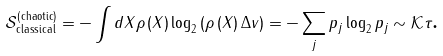<formula> <loc_0><loc_0><loc_500><loc_500>\mathcal { S } _ { \text {classical} } ^ { \left ( \text {chaotic} \right ) } = - \int d X \rho \left ( X \right ) \log _ { 2 } \left ( \rho \left ( X \right ) \Delta v \right ) = - \sum _ { j } p _ { j } \log _ { 2 } p _ { j } \sim \mathcal { K } \tau \text {.}</formula> 